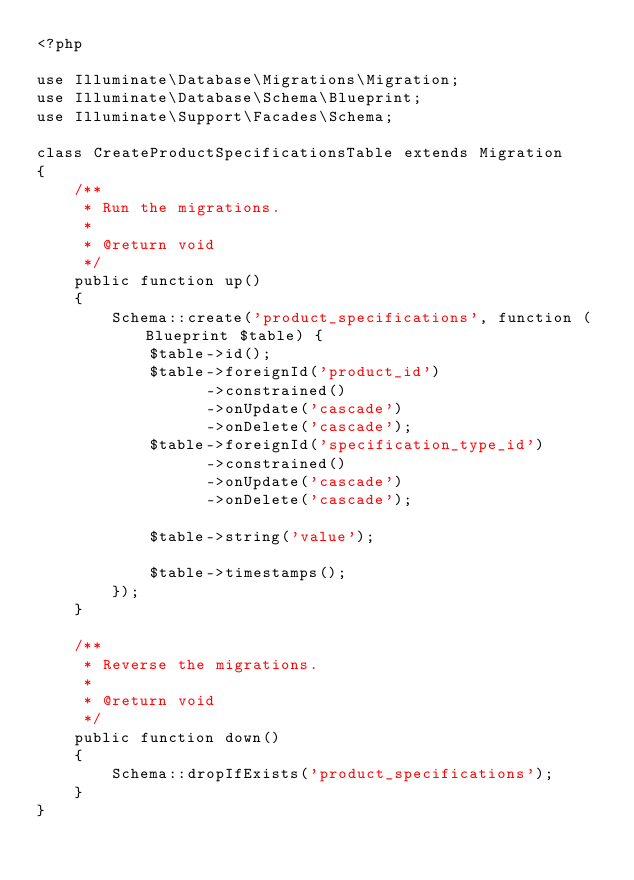<code> <loc_0><loc_0><loc_500><loc_500><_PHP_><?php

use Illuminate\Database\Migrations\Migration;
use Illuminate\Database\Schema\Blueprint;
use Illuminate\Support\Facades\Schema;

class CreateProductSpecificationsTable extends Migration
{
    /**
     * Run the migrations.
     *
     * @return void
     */
    public function up()
    {
        Schema::create('product_specifications', function (Blueprint $table) {
            $table->id();
            $table->foreignId('product_id')
                  ->constrained()
                  ->onUpdate('cascade')
                  ->onDelete('cascade');
            $table->foreignId('specification_type_id')
                  ->constrained()
                  ->onUpdate('cascade')
                  ->onDelete('cascade');

            $table->string('value');
            
            $table->timestamps();
        });
    }

    /**
     * Reverse the migrations.
     *
     * @return void
     */
    public function down()
    {
        Schema::dropIfExists('product_specifications');
    }
}
</code> 